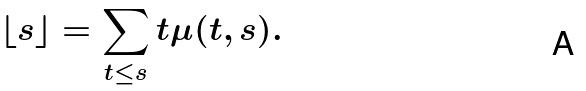Convert formula to latex. <formula><loc_0><loc_0><loc_500><loc_500>\lfloor s \rfloor = \sum _ { t \leq s } t \mu ( t , s ) .</formula> 